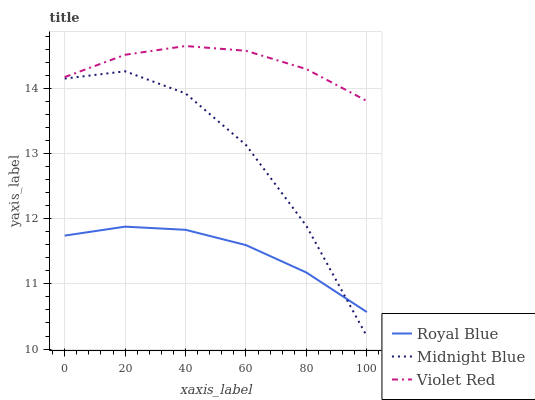Does Royal Blue have the minimum area under the curve?
Answer yes or no. Yes. Does Violet Red have the maximum area under the curve?
Answer yes or no. Yes. Does Midnight Blue have the minimum area under the curve?
Answer yes or no. No. Does Midnight Blue have the maximum area under the curve?
Answer yes or no. No. Is Royal Blue the smoothest?
Answer yes or no. Yes. Is Midnight Blue the roughest?
Answer yes or no. Yes. Is Violet Red the smoothest?
Answer yes or no. No. Is Violet Red the roughest?
Answer yes or no. No. Does Midnight Blue have the lowest value?
Answer yes or no. Yes. Does Violet Red have the lowest value?
Answer yes or no. No. Does Violet Red have the highest value?
Answer yes or no. Yes. Does Midnight Blue have the highest value?
Answer yes or no. No. Is Royal Blue less than Violet Red?
Answer yes or no. Yes. Is Violet Red greater than Royal Blue?
Answer yes or no. Yes. Does Royal Blue intersect Midnight Blue?
Answer yes or no. Yes. Is Royal Blue less than Midnight Blue?
Answer yes or no. No. Is Royal Blue greater than Midnight Blue?
Answer yes or no. No. Does Royal Blue intersect Violet Red?
Answer yes or no. No. 